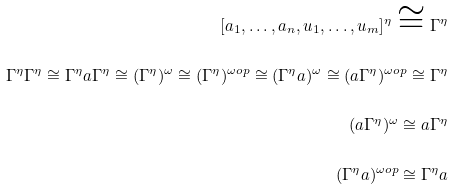<formula> <loc_0><loc_0><loc_500><loc_500>[ a _ { 1 } , \dots , a _ { n } , u _ { 1 } , \dots , u _ { m } ] ^ { \eta } \cong \Gamma ^ { \eta } \\ \Gamma ^ { \eta } \Gamma ^ { \eta } \cong \Gamma ^ { \eta } a \Gamma ^ { \eta } \cong ( \Gamma ^ { \eta } ) ^ { \omega } \cong ( \Gamma ^ { \eta } ) ^ { \omega o p } \cong ( \Gamma ^ { \eta } a ) ^ { \omega } \cong ( a \Gamma ^ { \eta } ) ^ { \omega o p } \cong \Gamma ^ { \eta } \\ ( a \Gamma ^ { \eta } ) ^ { \omega } \cong a \Gamma ^ { \eta } \\ ( \Gamma ^ { \eta } a ) ^ { \omega o p } \cong \Gamma ^ { \eta } a</formula> 